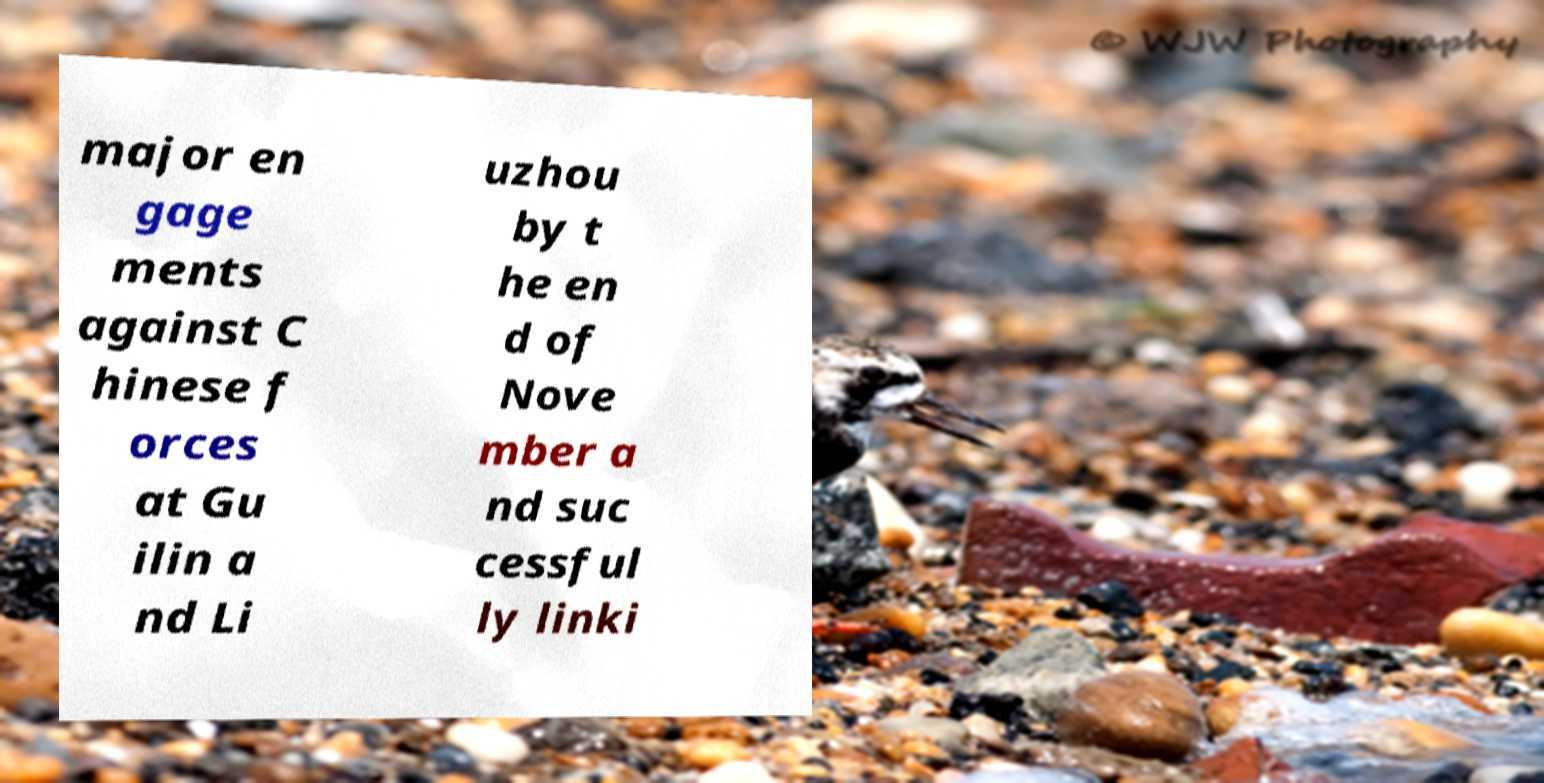Please read and relay the text visible in this image. What does it say? major en gage ments against C hinese f orces at Gu ilin a nd Li uzhou by t he en d of Nove mber a nd suc cessful ly linki 